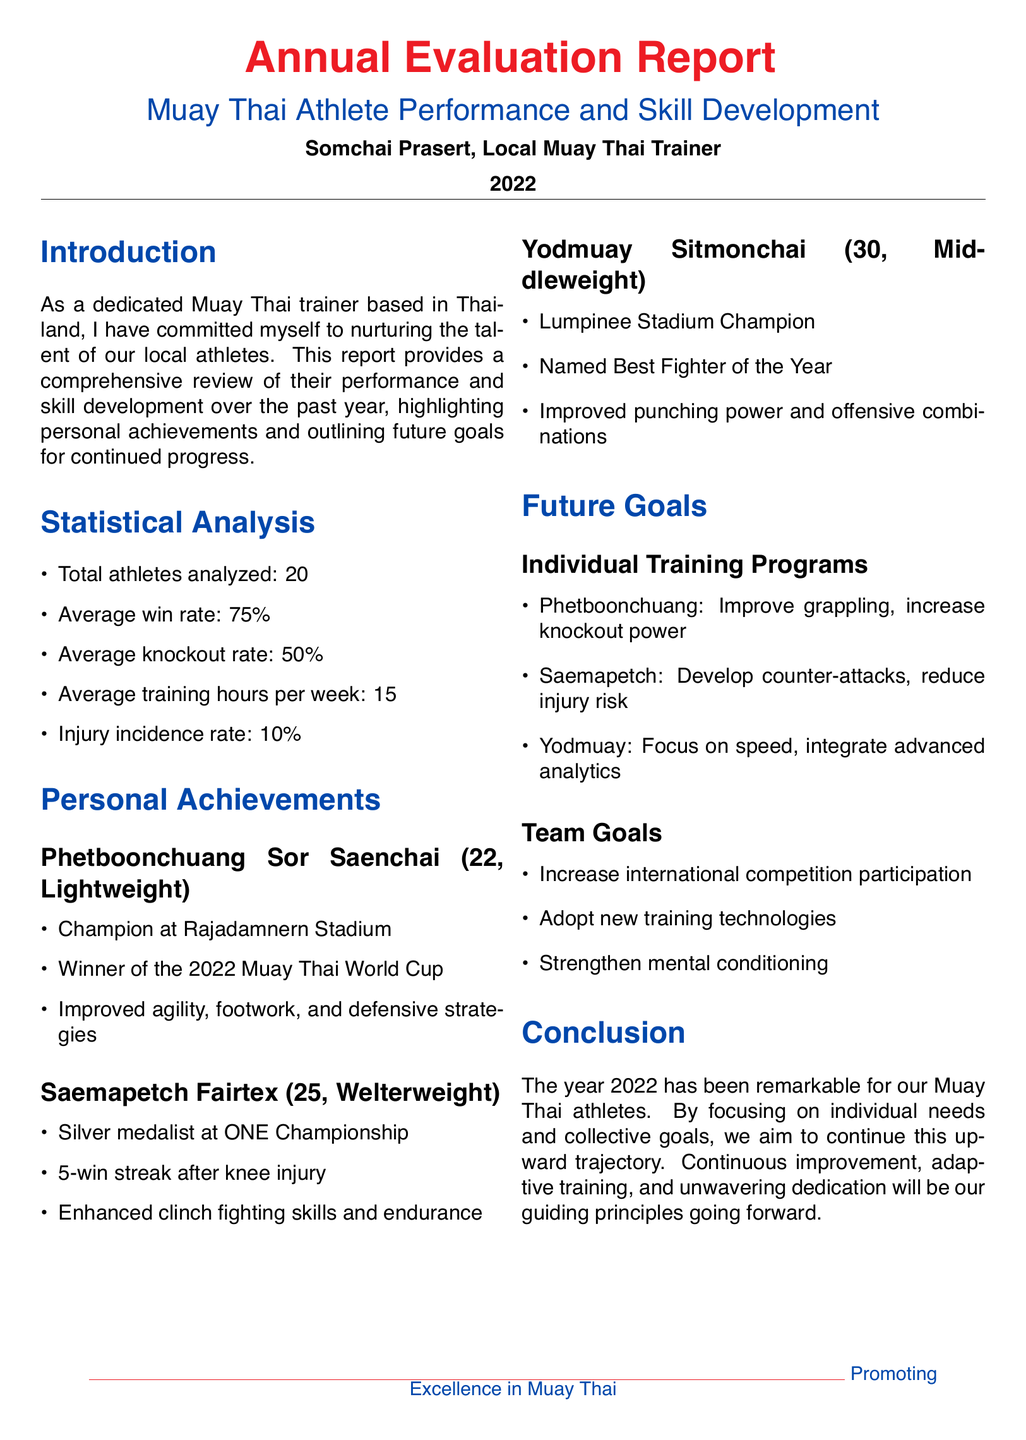what is the total number of athletes analyzed? The document states that 20 athletes were analyzed for their performance and skill development.
Answer: 20 what is the average win rate of the athletes? The average win rate is provided in the statistical analysis section of the document as 75%.
Answer: 75% who is the champion at Rajadamnern Stadium? The document identifies Phetboonchuang Sor Saenchai as the champion at Rajadamnern Stadium in the personal achievements section.
Answer: Phetboonchuang Sor Saenchai what medal did Saemapetch Fairtex win at ONE Championship? The report mentions that Saemapetch Fairtex was the silver medalist at ONE Championship.
Answer: Silver what improvement does Yodmuay Sitmonchai aim for? The document outlines that Yodmuay Sitmonchai aims to focus on speed, which is listed under future goals for individual training programs.
Answer: Speed what is the average training hours per week? The average training hours per week for the athletes is specifically stated in the statistical analysis section as 15 hours.
Answer: 15 what is the injury incidence rate among the athletes? The injury incidence rate is mentioned in the statistical analysis as being 10%.
Answer: 10% what is the primary focus for team goals moving forward? The document lists adopting new training technologies as a primary focus for team goals.
Answer: New training technologies who is named Best Fighter of the Year? The report states that Yodmuay Sitmonchai was named Best Fighter of the Year.
Answer: Yodmuay Sitmonchai 